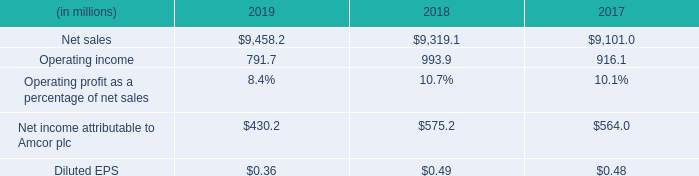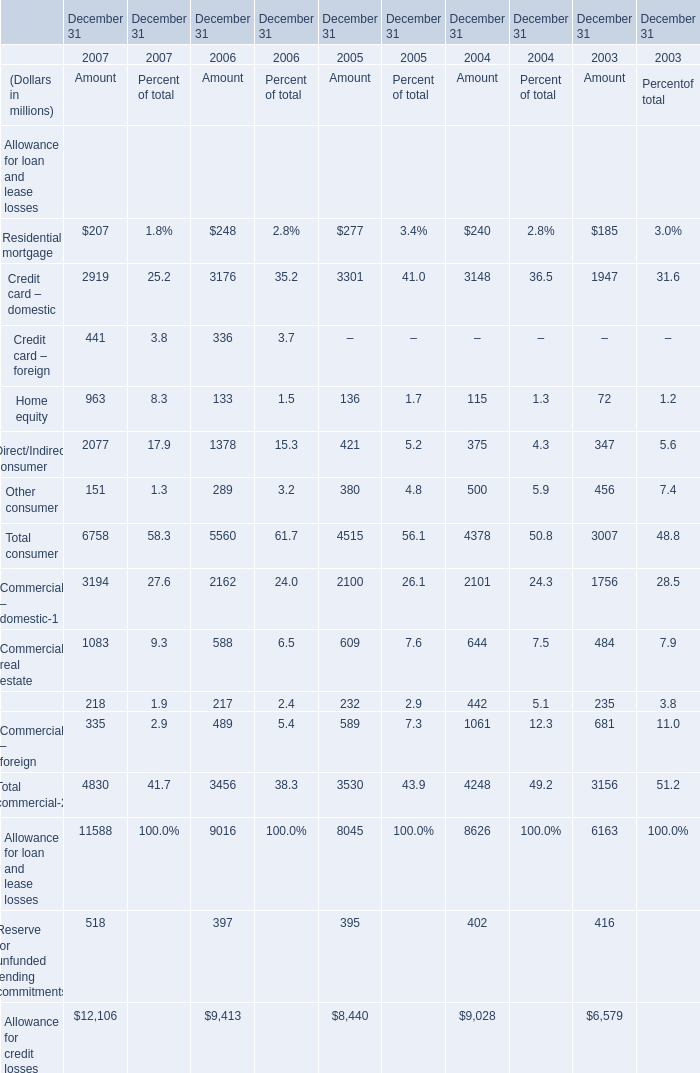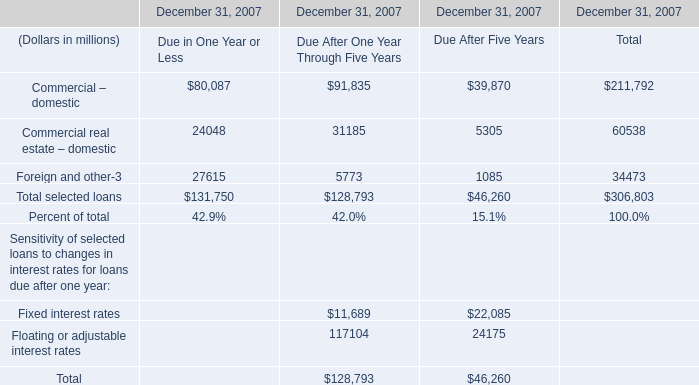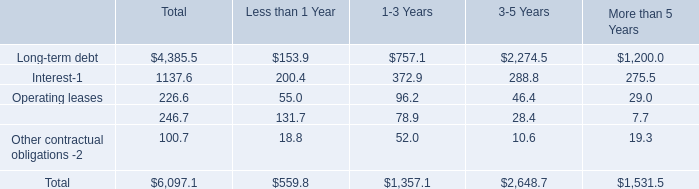What's the average of Residential mortgage in 2007 and 2006? (in million) 
Computations: ((207 + 248) / 2)
Answer: 227.5. 